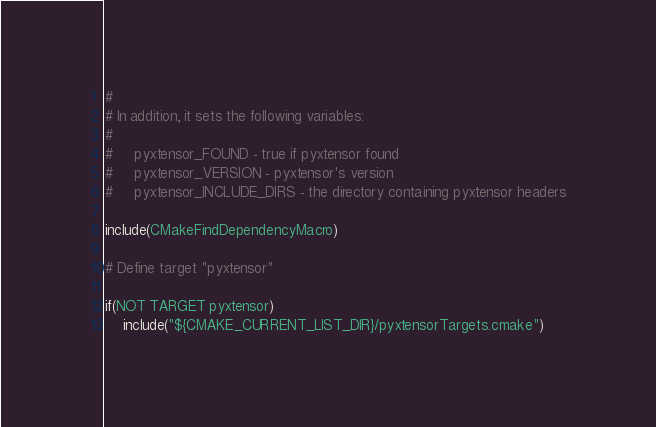<code> <loc_0><loc_0><loc_500><loc_500><_CMake_>#
# In addition, it sets the following variables:
#
#     pyxtensor_FOUND - true if pyxtensor found
#     pyxtensor_VERSION - pyxtensor's version
#     pyxtensor_INCLUDE_DIRS - the directory containing pyxtensor headers

include(CMakeFindDependencyMacro)

# Define target "pyxtensor"

if(NOT TARGET pyxtensor)
    include("${CMAKE_CURRENT_LIST_DIR}/pyxtensorTargets.cmake")</code> 